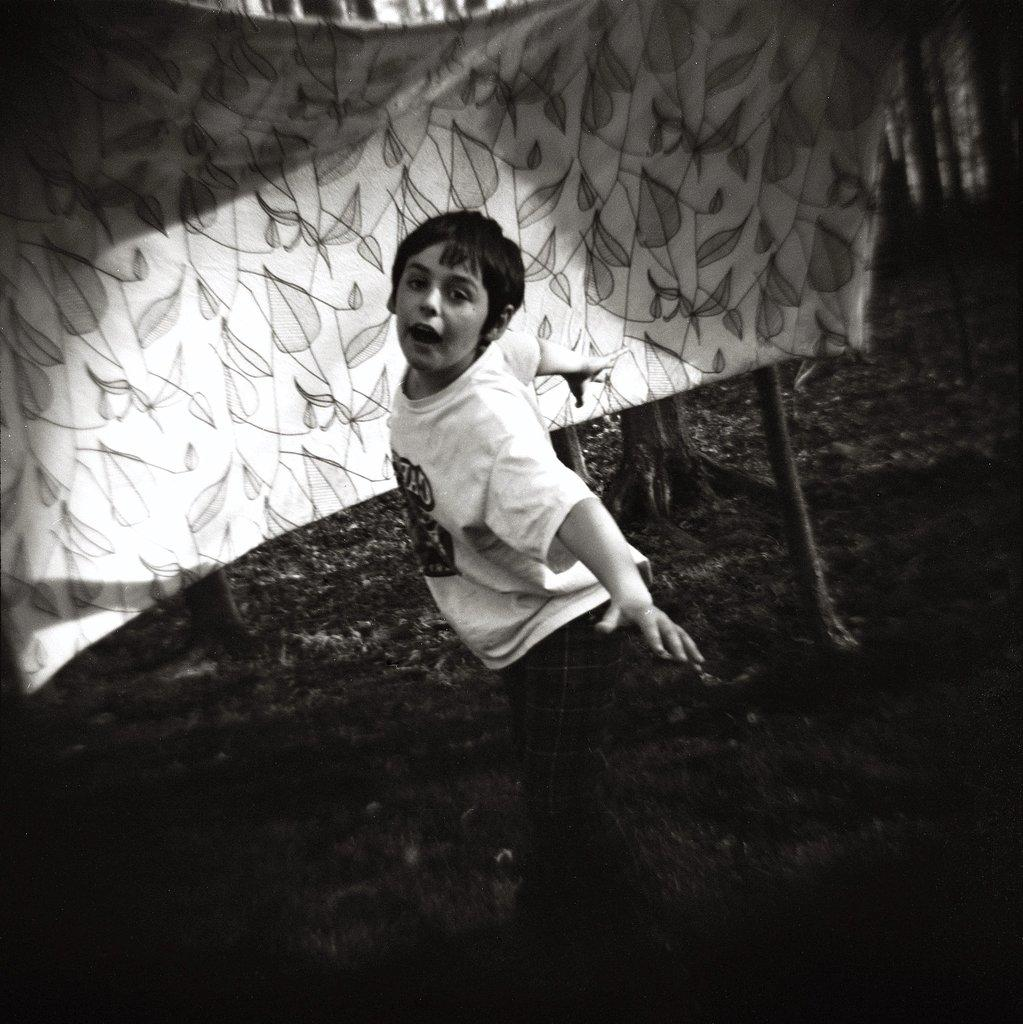What is the color scheme of the image? The image is black and white. Who or what is the main subject in the picture? There is a boy in the picture. What object can be seen in the image besides the boy? There is a pole in the picture. What can be seen in the background of the image? There is a cloth visible in the background of the picture. How does the earthquake affect the boy in the image? There is no earthquake present in the image; it is a black and white picture featuring a boy, a pole, and a cloth in the background. 